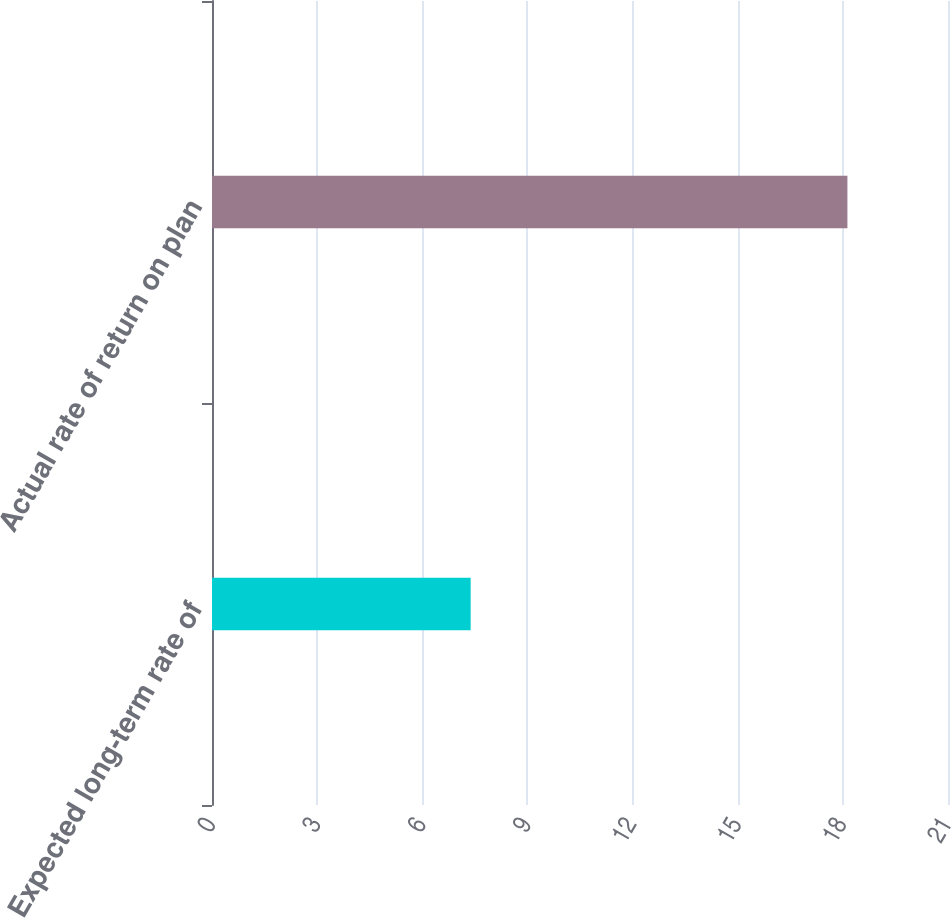<chart> <loc_0><loc_0><loc_500><loc_500><bar_chart><fcel>Expected long-term rate of<fcel>Actual rate of return on plan<nl><fcel>7.38<fcel>18.13<nl></chart> 